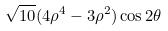<formula> <loc_0><loc_0><loc_500><loc_500>\sqrt { 1 0 } ( 4 \rho ^ { 4 } - 3 \rho ^ { 2 } ) \cos 2 \theta</formula> 